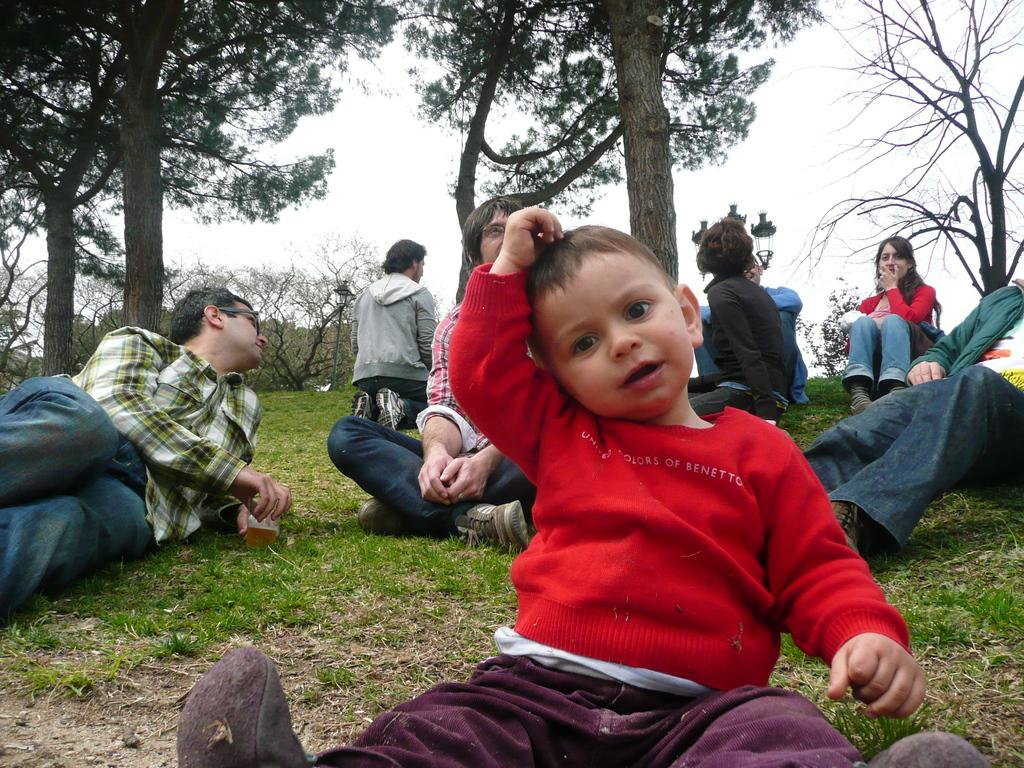What is the kid doing in the image? The kid is sitting on the grass surface in the image. Are there any other people in the image? Yes, there are people sitting on the grass surface behind the kid. What can be seen in the background of the image? There are trees and a lamp post visible in the background of the image. What type of toe is visible on the kid's foot in the image? There is no visible toe on the kid's foot in the image, as the kid is sitting and their feet are not shown. 